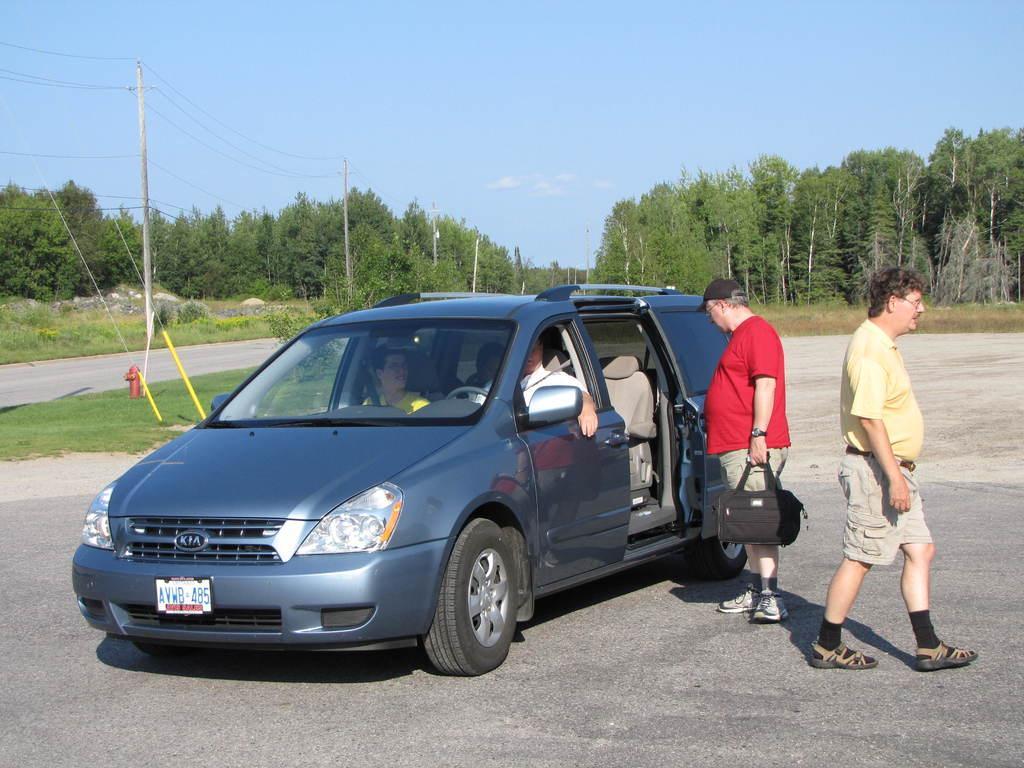How would you summarize this image in a sentence or two? In that given picture there are two men and walking on the road. And there is a car in blue color. In the background there are some trees and electric poles located. We can observe a sky here. 